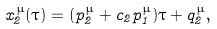Convert formula to latex. <formula><loc_0><loc_0><loc_500><loc_500>x _ { 2 } ^ { \mu } ( \tau ) = ( p _ { 2 } ^ { \mu } + c _ { 2 } p _ { 1 } ^ { \mu } ) \tau + q _ { 2 } ^ { \mu } ,</formula> 